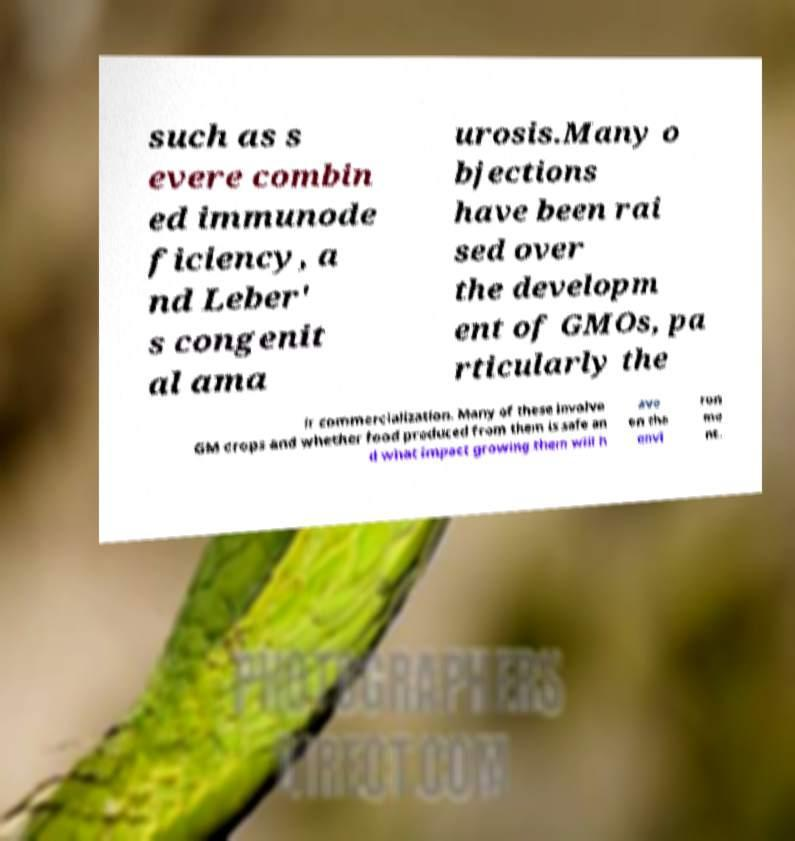Please identify and transcribe the text found in this image. such as s evere combin ed immunode ficiency, a nd Leber' s congenit al ama urosis.Many o bjections have been rai sed over the developm ent of GMOs, pa rticularly the ir commercialization. Many of these involve GM crops and whether food produced from them is safe an d what impact growing them will h ave on the envi ron me nt. 